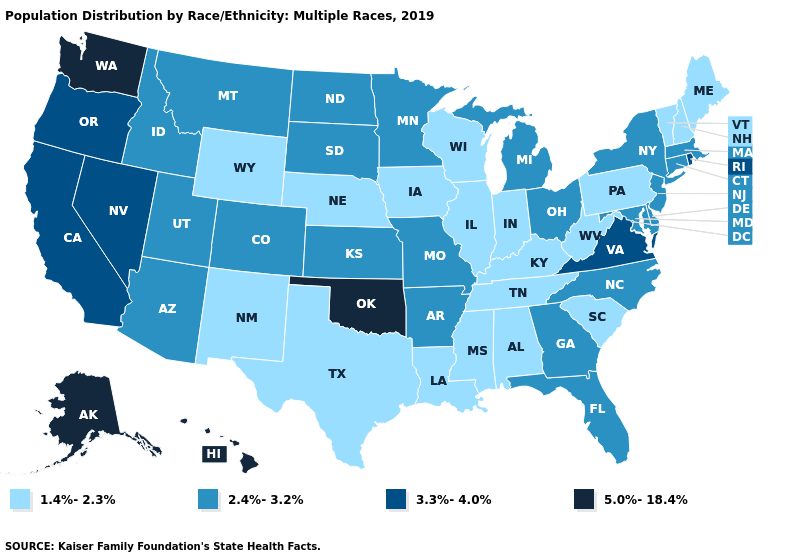What is the value of Nebraska?
Write a very short answer. 1.4%-2.3%. Which states have the lowest value in the West?
Concise answer only. New Mexico, Wyoming. What is the highest value in the West ?
Be succinct. 5.0%-18.4%. Does Alaska have the highest value in the USA?
Keep it brief. Yes. What is the value of Maryland?
Be succinct. 2.4%-3.2%. Name the states that have a value in the range 1.4%-2.3%?
Write a very short answer. Alabama, Illinois, Indiana, Iowa, Kentucky, Louisiana, Maine, Mississippi, Nebraska, New Hampshire, New Mexico, Pennsylvania, South Carolina, Tennessee, Texas, Vermont, West Virginia, Wisconsin, Wyoming. How many symbols are there in the legend?
Keep it brief. 4. Does Massachusetts have the lowest value in the USA?
Give a very brief answer. No. Name the states that have a value in the range 2.4%-3.2%?
Quick response, please. Arizona, Arkansas, Colorado, Connecticut, Delaware, Florida, Georgia, Idaho, Kansas, Maryland, Massachusetts, Michigan, Minnesota, Missouri, Montana, New Jersey, New York, North Carolina, North Dakota, Ohio, South Dakota, Utah. What is the highest value in the South ?
Write a very short answer. 5.0%-18.4%. Name the states that have a value in the range 1.4%-2.3%?
Keep it brief. Alabama, Illinois, Indiana, Iowa, Kentucky, Louisiana, Maine, Mississippi, Nebraska, New Hampshire, New Mexico, Pennsylvania, South Carolina, Tennessee, Texas, Vermont, West Virginia, Wisconsin, Wyoming. Name the states that have a value in the range 2.4%-3.2%?
Be succinct. Arizona, Arkansas, Colorado, Connecticut, Delaware, Florida, Georgia, Idaho, Kansas, Maryland, Massachusetts, Michigan, Minnesota, Missouri, Montana, New Jersey, New York, North Carolina, North Dakota, Ohio, South Dakota, Utah. What is the value of Maryland?
Quick response, please. 2.4%-3.2%. Among the states that border Montana , which have the highest value?
Give a very brief answer. Idaho, North Dakota, South Dakota. Among the states that border Louisiana , does Texas have the lowest value?
Keep it brief. Yes. 